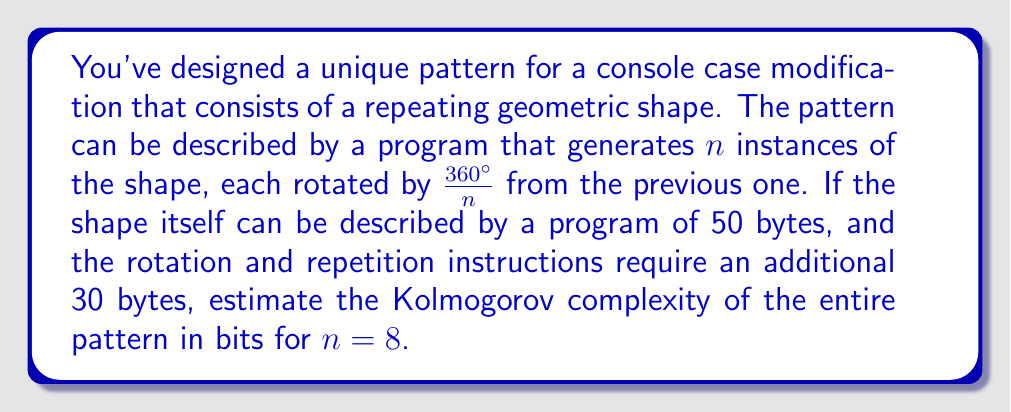Could you help me with this problem? To estimate the Kolmogorov complexity of the console case modification pattern, we need to consider the length of the shortest program that can generate the pattern. Let's break this down step-by-step:

1. The base shape description:
   - Given: 50 bytes
   - Convert to bits: $50 \times 8 = 400$ bits

2. The rotation and repetition instructions:
   - Given: 30 bytes
   - Convert to bits: $30 \times 8 = 240$ bits

3. The number of repetitions:
   - $n = 8$
   - To represent 8 in binary: $2^3 = 8$, so we need 3 bits

4. Total program length:
   $$\text{Total bits} = \text{Shape description} + \text{Instructions} + \text{Repetition count}$$
   $$\text{Total bits} = 400 + 240 + 3 = 643 \text{ bits}$$

5. Kolmogorov complexity:
   The Kolmogorov complexity is defined as the length of the shortest program that can produce the given output. In this case, our estimate of the Kolmogorov complexity is the total length of the program we've described.

Note: This is an upper bound estimate of the Kolmogorov complexity. The actual Kolmogorov complexity might be lower if there exists a more efficient way to describe the pattern.
Answer: The estimated Kolmogorov complexity of the console case modification pattern is 643 bits. 